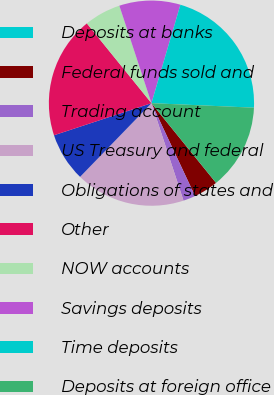Convert chart. <chart><loc_0><loc_0><loc_500><loc_500><pie_chart><fcel>Deposits at banks<fcel>Federal funds sold and<fcel>Trading account<fcel>US Treasury and federal<fcel>Obligations of states and<fcel>Other<fcel>NOW accounts<fcel>Savings deposits<fcel>Time deposits<fcel>Deposits at foreign office<nl><fcel>0.0%<fcel>3.85%<fcel>1.93%<fcel>17.3%<fcel>7.69%<fcel>19.23%<fcel>5.77%<fcel>9.62%<fcel>21.15%<fcel>13.46%<nl></chart> 